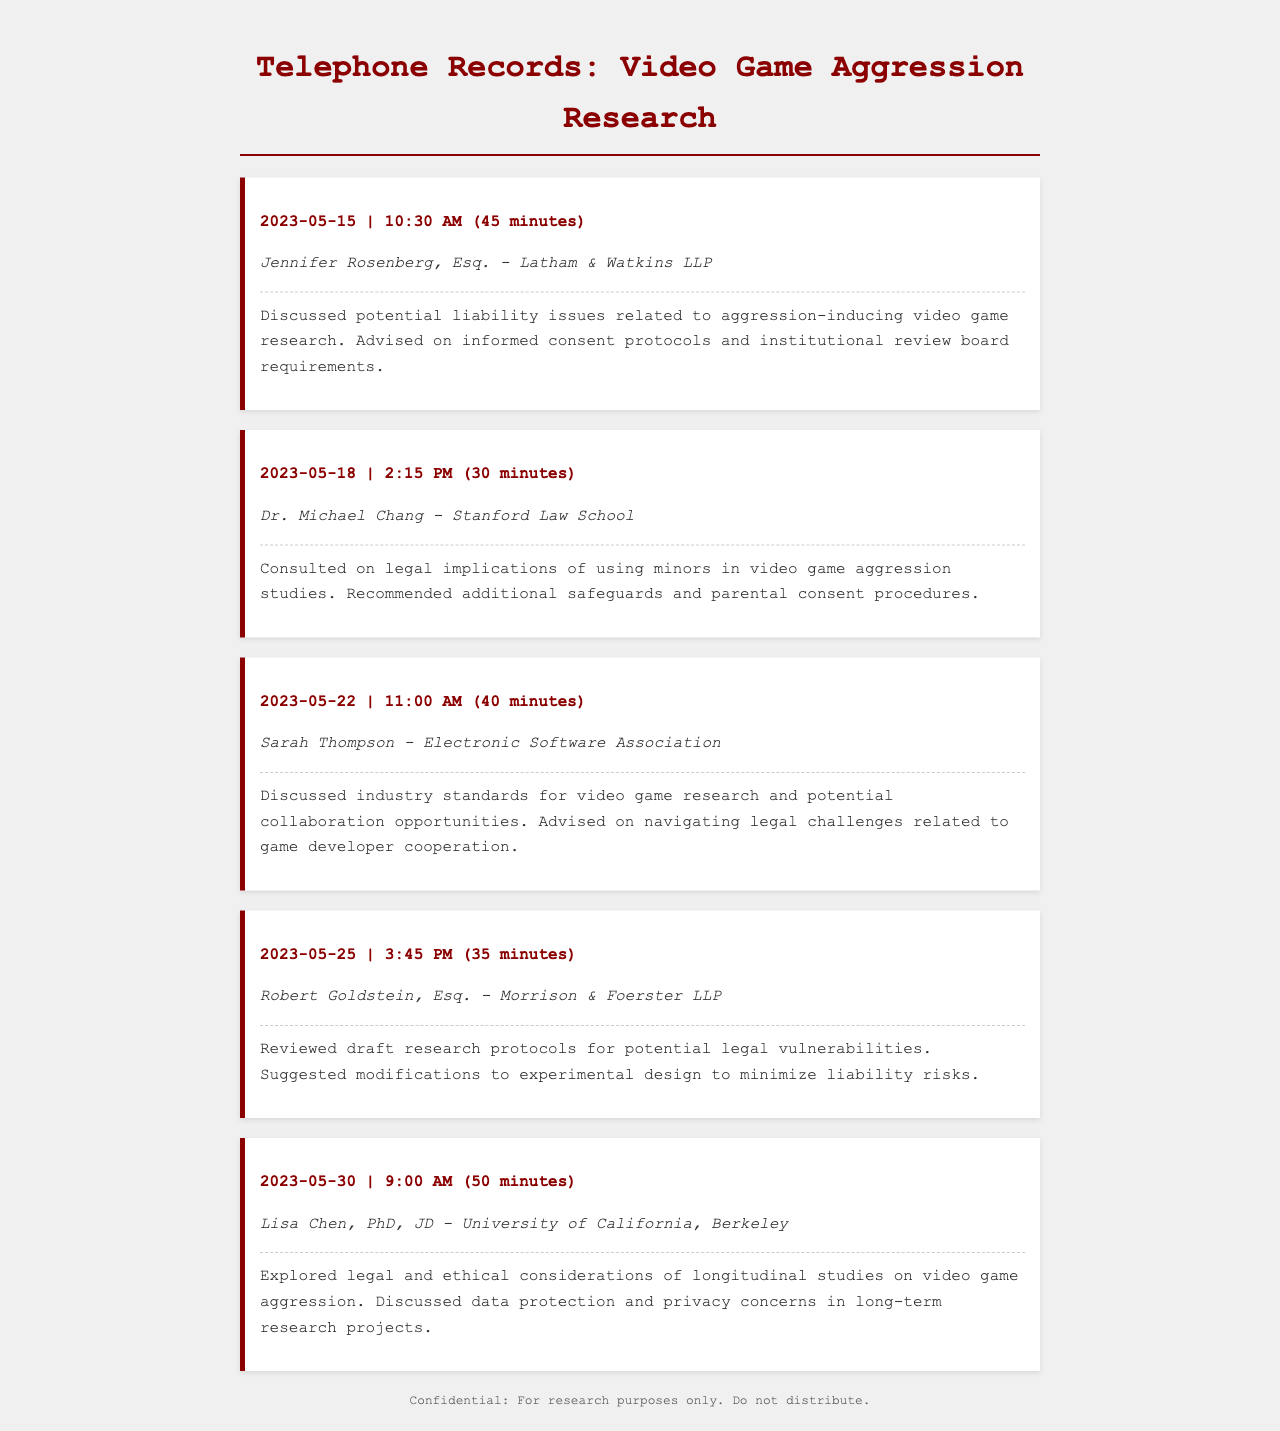What is the date of the first consultation? The first consultation occurred on May 15, 2023, as indicated in the document.
Answer: May 15, 2023 Who was the legal expert consulted on May 22, 2023? The expert consulted on May 22, 2023, was Sarah Thompson, as stated in the document.
Answer: Sarah Thompson What was the duration of the consultation with Jennifer Rosenberg? The duration of the consultation is provided in the document as 45 minutes.
Answer: 45 minutes What institution is Dr. Michael Chang affiliated with? The document specifies that Dr. Michael Chang is from Stanford Law School.
Answer: Stanford Law School Which legal issue was discussed on May 30, 2023? The document notes that legal and ethical considerations were explored regarding longitudinal studies.
Answer: Longitudinal studies on video game aggression What recommendation was given regarding minors in video game research? The document states that additional safeguards and parental consent procedures were recommended.
Answer: Additional safeguards and parental consent procedures Who reviewed the draft research protocols? The document reveals that Robert Goldstein reviewed the draft research protocols for potential legal vulnerabilities.
Answer: Robert Goldstein What is the focus of the consultations recorded in this document? The consultations focus on potential liability issues related to aggression-inducing video game research, as clearly stated.
Answer: Potential liability issues 